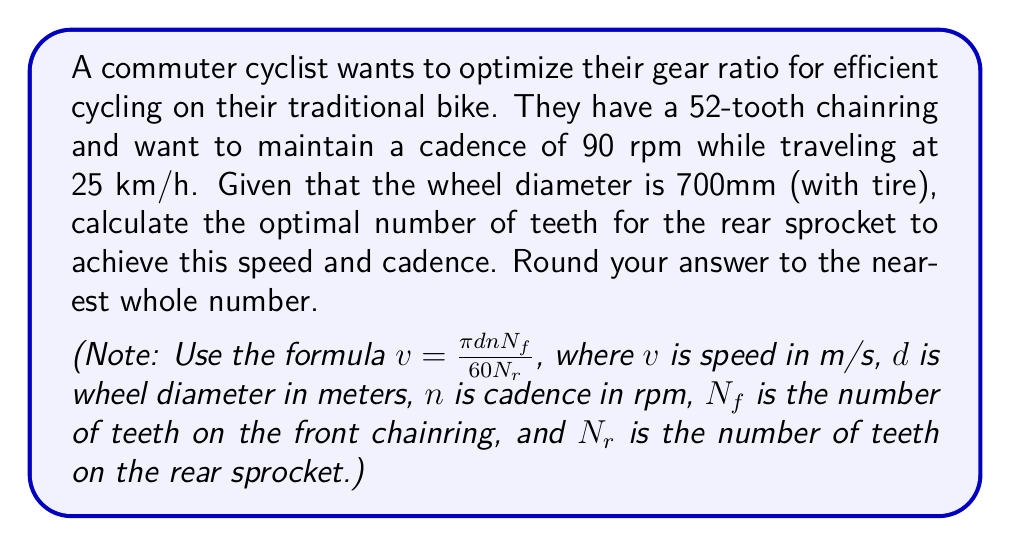Can you answer this question? To solve this problem, we'll use the given formula and follow these steps:

1. Convert the given speed from km/h to m/s:
   $25 \text{ km/h} = 25 \times \frac{1000 \text{ m}}{3600 \text{ s}} = 6.94 \text{ m/s}$

2. Convert the wheel diameter from mm to m:
   $700 \text{ mm} = 0.7 \text{ m}$

3. Substitute the known values into the formula:
   $6.94 = \frac{\pi \times 0.7 \times 90 \times 52}{60 N_r}$

4. Solve for $N_r$:
   $$\begin{align}
   6.94 &= \frac{\pi \times 0.7 \times 90 \times 52}{60 N_r} \\
   6.94 \times 60 N_r &= \pi \times 0.7 \times 90 \times 52 \\
   416.4 N_r &= 10,214.51 \\
   N_r &= \frac{10,214.51}{416.4} \\
   N_r &\approx 24.53
   \end{align}$$

5. Round to the nearest whole number:
   $N_r \approx 25$ teeth

Therefore, the optimal number of teeth for the rear sprocket is 25.
Answer: 25 teeth 